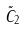Convert formula to latex. <formula><loc_0><loc_0><loc_500><loc_500>\tilde { C } _ { 2 }</formula> 